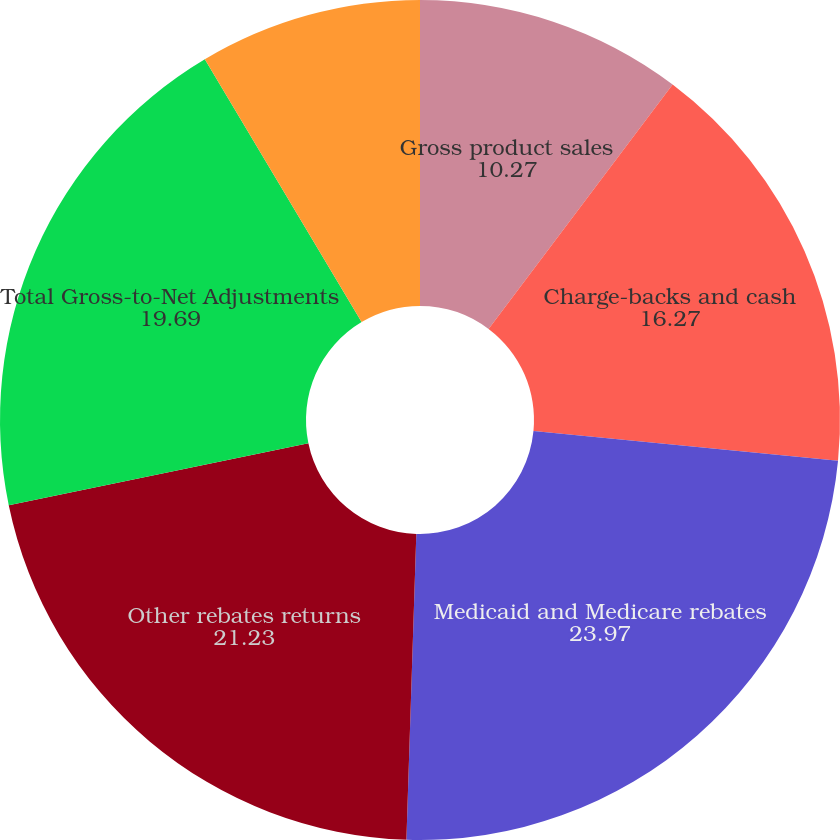Convert chart. <chart><loc_0><loc_0><loc_500><loc_500><pie_chart><fcel>Gross product sales<fcel>Charge-backs and cash<fcel>Medicaid and Medicare rebates<fcel>Other rebates returns<fcel>Total Gross-to-Net Adjustments<fcel>Net product sales<nl><fcel>10.27%<fcel>16.27%<fcel>23.97%<fcel>21.23%<fcel>19.69%<fcel>8.56%<nl></chart> 